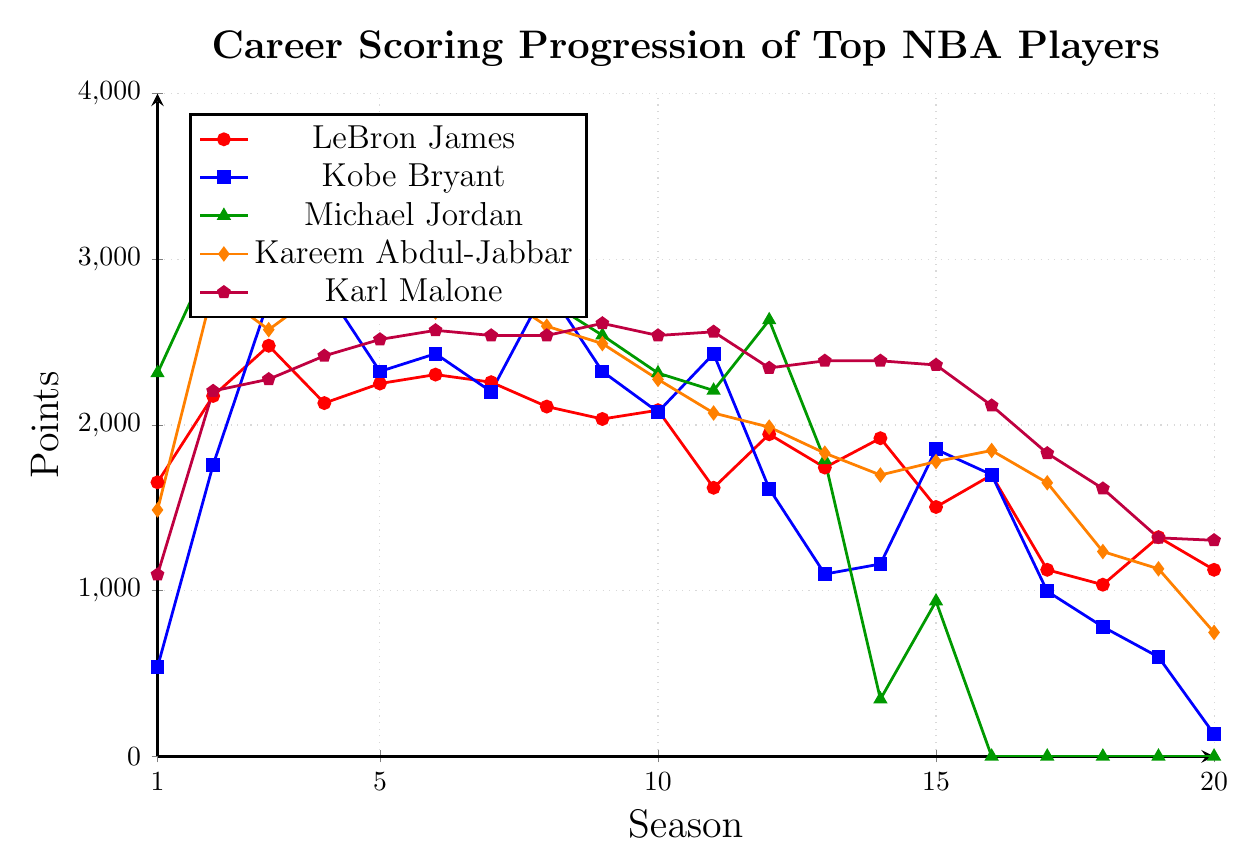What are the total points scored by LeBron James over all 20 seasons? Sum the points for each season: 1654 + 2175 + 2478 + 2132 + 2250 + 2304 + 2258 + 2111 + 2036 + 2089 + 1621 + 1944 + 1743 + 1920 + 1505 + 1698 + 1126 + 1036 + 1323 + 1126
Answer: 43089 In which season did Michael Jordan score the highest points and how many points did he score? Identify the highest point value for Michael Jordan and the corresponding season: Highest point value is 3636, which occurred in season 5
Answer: Season 5, 3636 points Which player had more consistent (less variable) scoring from season to season, Karl Malone or Kareem Abdul-Jabbar? Compare the points scored for each season; observe that Karl Malone's points vary less drastically than Kareem Abdul-Jabbar's, whose points can fluctuate by over 1000 points from season to season
Answer: Karl Malone Whose career had a more dramatic increase in scoring after the first season, LeBron James or Kobe Bryant? Calculate the difference in points scored between the first two seasons for both players: LeBron James: 2175 - 1654 = 521; Kobe Bryant: 1759 - 539 = 1220
Answer: Kobe Bryant In which season did Kareem Abdul-Jabbar first surpass 2500 points? Locate the first season where Kareem's points exceed 2500: Kareem first scores over 2500 in season 2 with 2822 points
Answer: Season 2 On average, how many points did Karl Malone score per season over his 20-season career? Sum Karl Malone's points and divide by 20: Total points = 1097 + 2205 + 2276 + 2417 + 2516 + 2571 + 2540 + 2540 + 2613 + 2540 + 2562 + 2344 + 2387 + 2387 + 2362 + 2117 + 1829 + 1616 + 1319 + 1304; Average = 47206 / 20 = 2360.3
Answer: 2360.3 Who scored the fewest points in their 20th season and how many points was it? Compare the points scored in the 20th season for all players: Kobe Bryant with 134 points
Answer: Kobe Bryant, 134 points Did any player score over 3000 points in their third season, and if so, who? Look at the points in the third season for each player: Michael Jordan scored 3041 points
Answer: Michael Jordan 